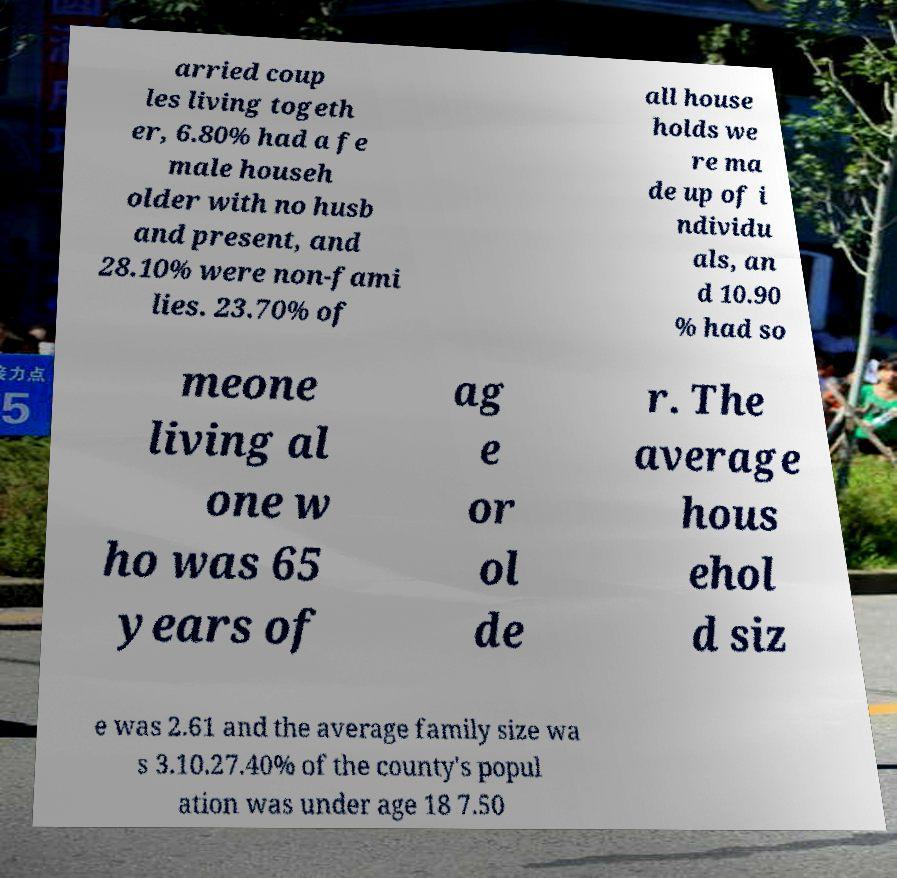Could you assist in decoding the text presented in this image and type it out clearly? arried coup les living togeth er, 6.80% had a fe male househ older with no husb and present, and 28.10% were non-fami lies. 23.70% of all house holds we re ma de up of i ndividu als, an d 10.90 % had so meone living al one w ho was 65 years of ag e or ol de r. The average hous ehol d siz e was 2.61 and the average family size wa s 3.10.27.40% of the county's popul ation was under age 18 7.50 